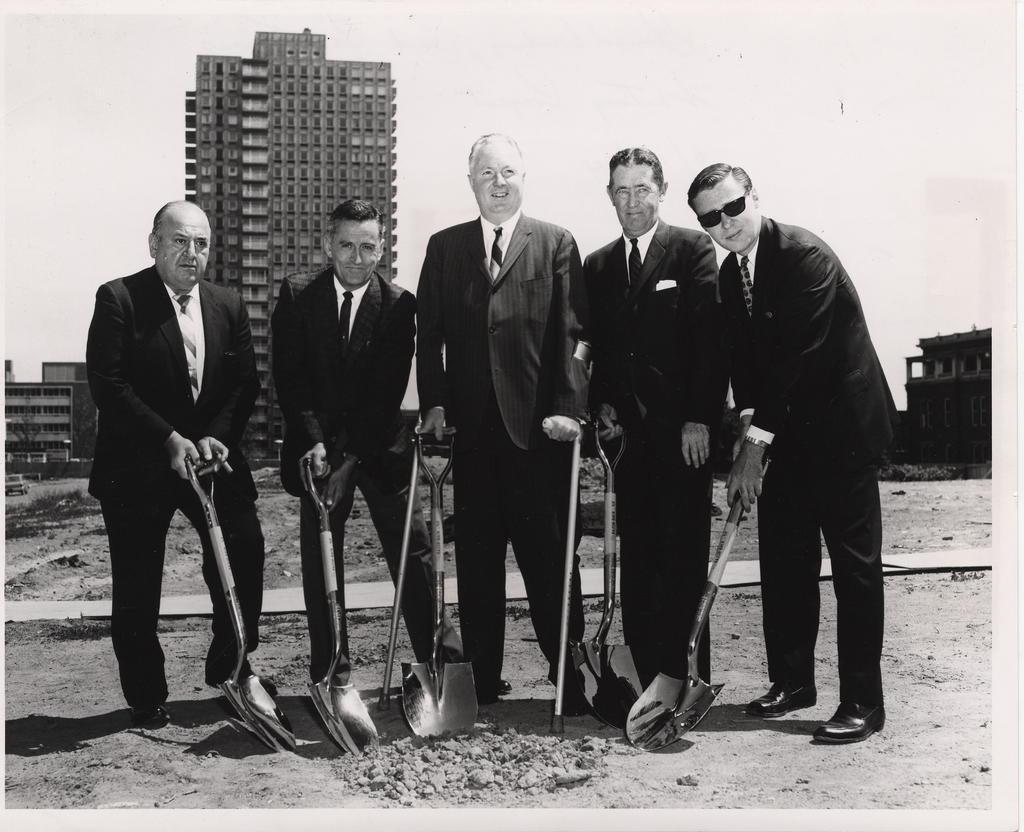Describe this image in one or two sentences. This is a black and white image where we can see five men are standing. They are wearing suits and holding shovels in their hands. We can see buildings, land and the sky in the background. 